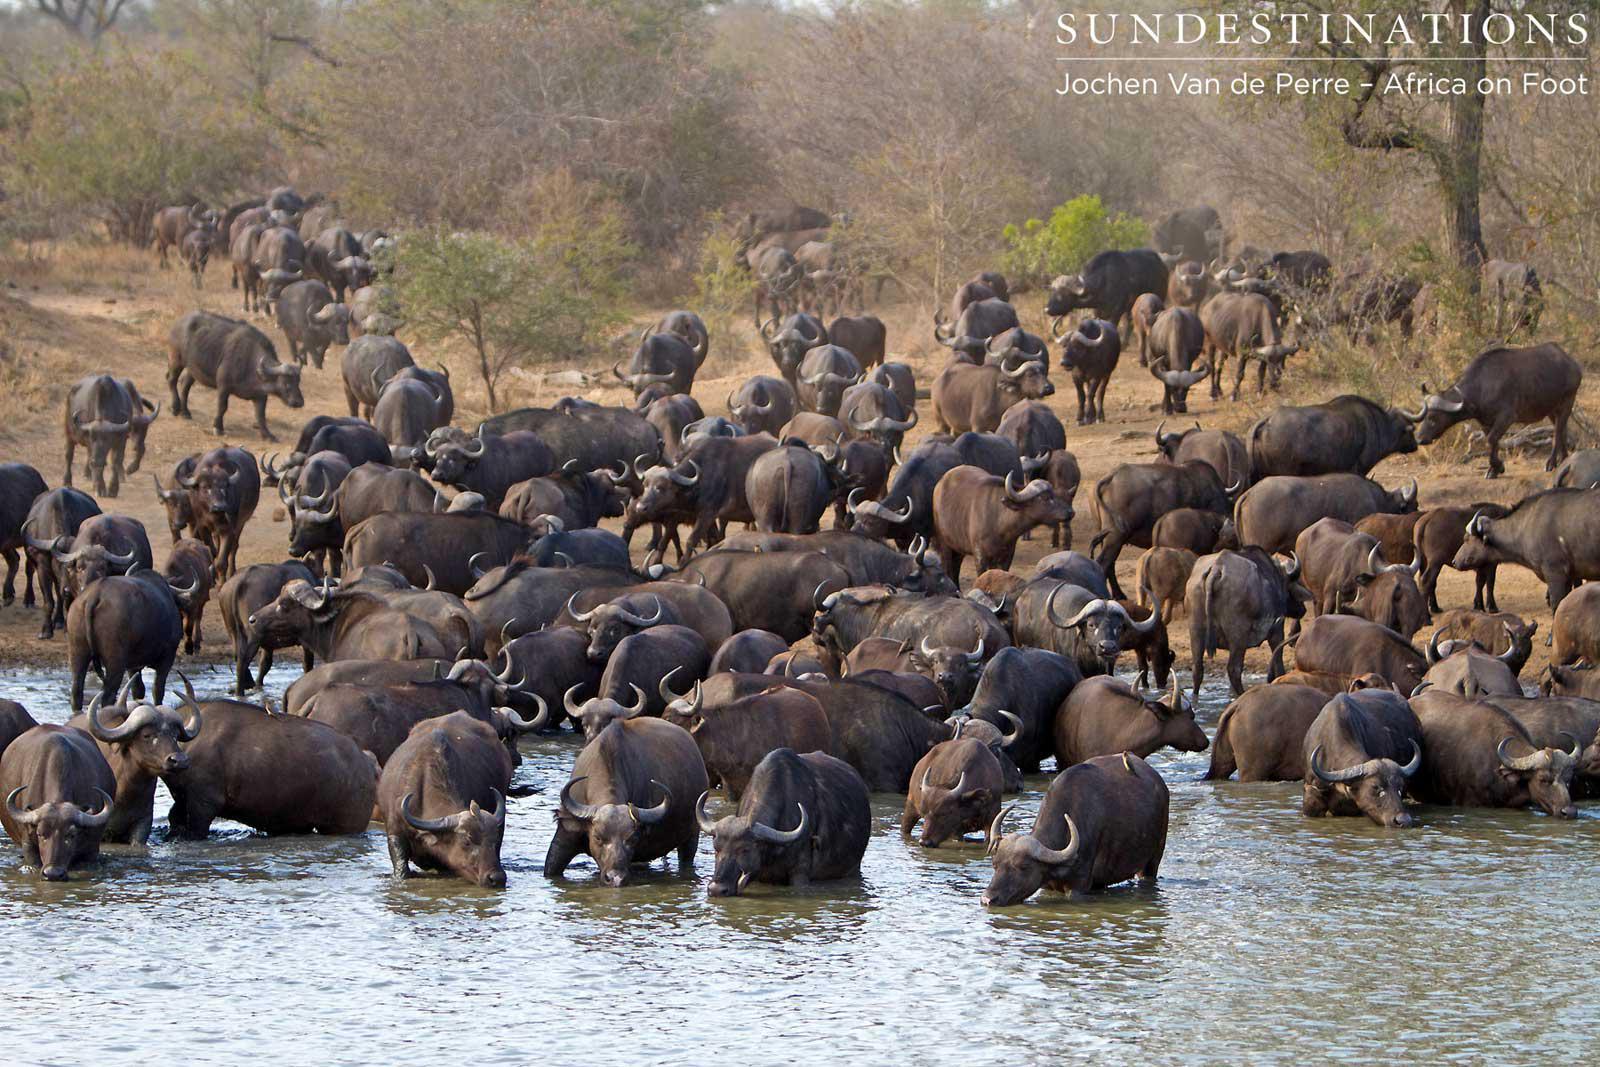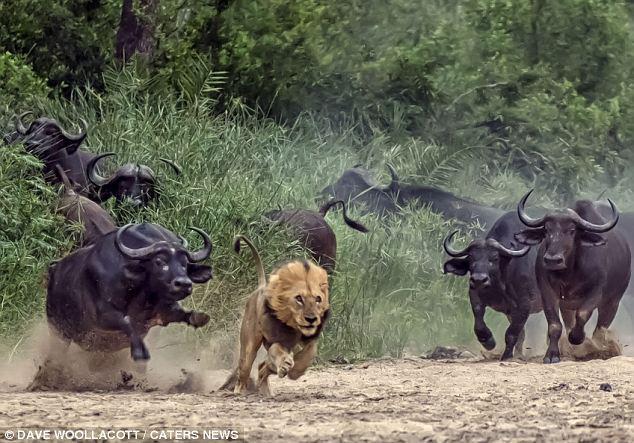The first image is the image on the left, the second image is the image on the right. Evaluate the accuracy of this statement regarding the images: "there are animals in the water in the image on the right side". Is it true? Answer yes or no. No. The first image is the image on the left, the second image is the image on the right. For the images displayed, is the sentence "All animals in the right image are on land." factually correct? Answer yes or no. Yes. 